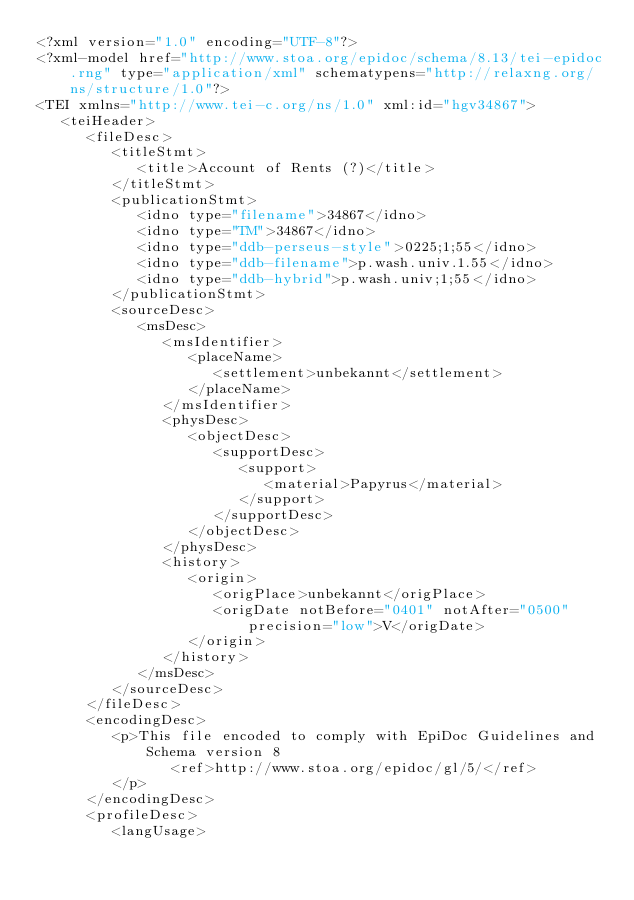<code> <loc_0><loc_0><loc_500><loc_500><_XML_><?xml version="1.0" encoding="UTF-8"?>
<?xml-model href="http://www.stoa.org/epidoc/schema/8.13/tei-epidoc.rng" type="application/xml" schematypens="http://relaxng.org/ns/structure/1.0"?>
<TEI xmlns="http://www.tei-c.org/ns/1.0" xml:id="hgv34867">
   <teiHeader>
      <fileDesc>
         <titleStmt>
            <title>Account of Rents (?)</title>
         </titleStmt>
         <publicationStmt>
            <idno type="filename">34867</idno>
            <idno type="TM">34867</idno>
            <idno type="ddb-perseus-style">0225;1;55</idno>
            <idno type="ddb-filename">p.wash.univ.1.55</idno>
            <idno type="ddb-hybrid">p.wash.univ;1;55</idno>
         </publicationStmt>
         <sourceDesc>
            <msDesc>
               <msIdentifier>
                  <placeName>
                     <settlement>unbekannt</settlement>
                  </placeName>
               </msIdentifier>
               <physDesc>
                  <objectDesc>
                     <supportDesc>
                        <support>
                           <material>Papyrus</material>
                        </support>
                     </supportDesc>
                  </objectDesc>
               </physDesc>
               <history>
                  <origin>
                     <origPlace>unbekannt</origPlace>
                     <origDate notBefore="0401" notAfter="0500" precision="low">V</origDate>
                  </origin>
               </history>
            </msDesc>
         </sourceDesc>
      </fileDesc>
      <encodingDesc>
         <p>This file encoded to comply with EpiDoc Guidelines and Schema version 8
                <ref>http://www.stoa.org/epidoc/gl/5/</ref>
         </p>
      </encodingDesc>
      <profileDesc>
         <langUsage></code> 